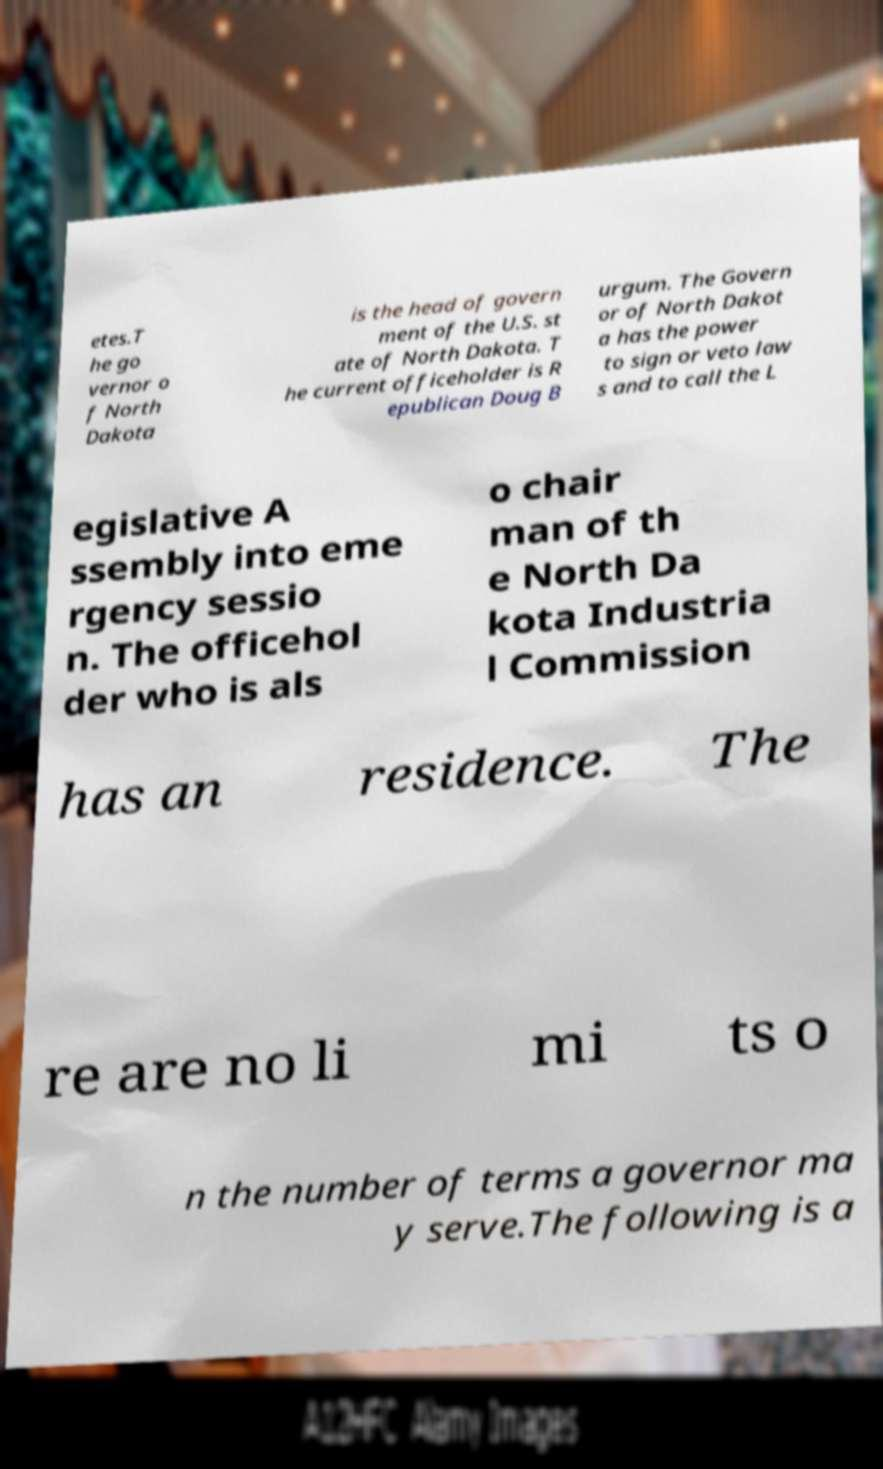Can you accurately transcribe the text from the provided image for me? etes.T he go vernor o f North Dakota is the head of govern ment of the U.S. st ate of North Dakota. T he current officeholder is R epublican Doug B urgum. The Govern or of North Dakot a has the power to sign or veto law s and to call the L egislative A ssembly into eme rgency sessio n. The officehol der who is als o chair man of th e North Da kota Industria l Commission has an residence. The re are no li mi ts o n the number of terms a governor ma y serve.The following is a 